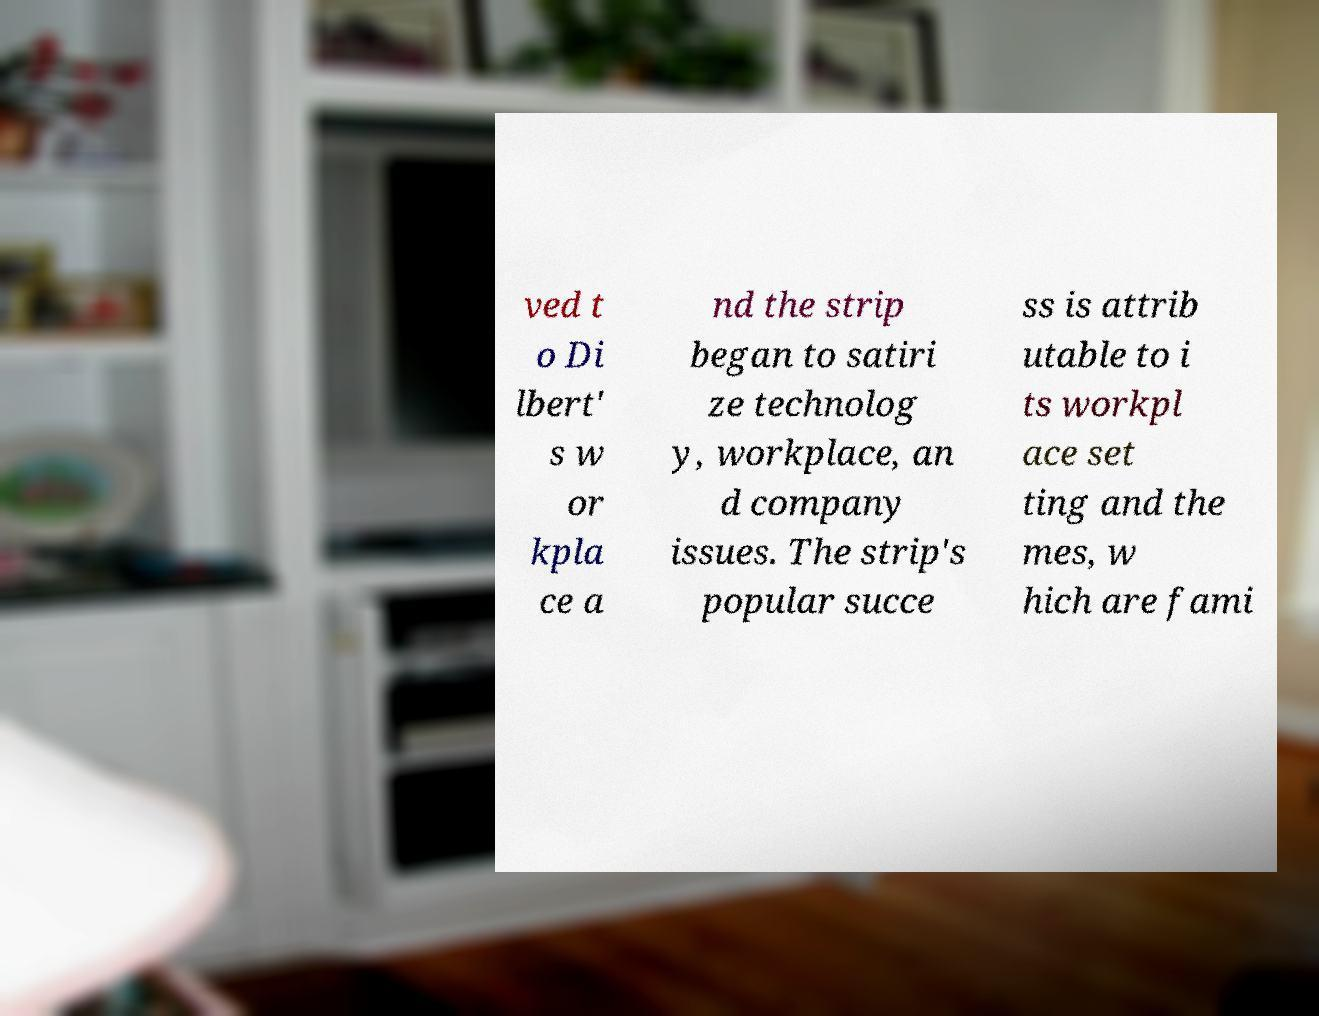Could you assist in decoding the text presented in this image and type it out clearly? ved t o Di lbert' s w or kpla ce a nd the strip began to satiri ze technolog y, workplace, an d company issues. The strip's popular succe ss is attrib utable to i ts workpl ace set ting and the mes, w hich are fami 